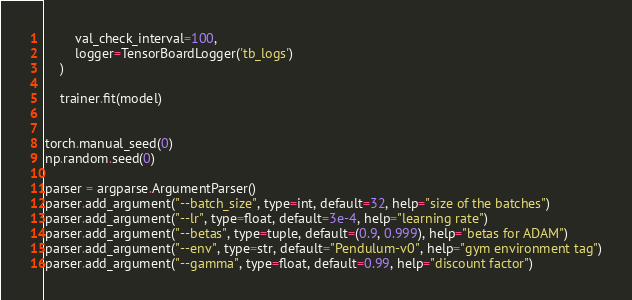Convert code to text. <code><loc_0><loc_0><loc_500><loc_500><_Python_>        val_check_interval=100,
        logger=TensorBoardLogger('tb_logs')
    )

    trainer.fit(model)


torch.manual_seed(0)
np.random.seed(0)

parser = argparse.ArgumentParser()
parser.add_argument("--batch_size", type=int, default=32, help="size of the batches")
parser.add_argument("--lr", type=float, default=3e-4, help="learning rate")
parser.add_argument("--betas", type=tuple, default=(0.9, 0.999), help="betas for ADAM")
parser.add_argument("--env", type=str, default="Pendulum-v0", help="gym environment tag")
parser.add_argument("--gamma", type=float, default=0.99, help="discount factor")</code> 